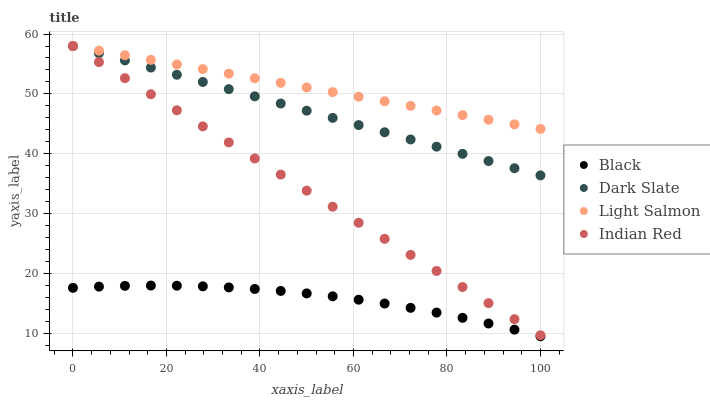Does Black have the minimum area under the curve?
Answer yes or no. Yes. Does Light Salmon have the maximum area under the curve?
Answer yes or no. Yes. Does Light Salmon have the minimum area under the curve?
Answer yes or no. No. Does Black have the maximum area under the curve?
Answer yes or no. No. Is Indian Red the smoothest?
Answer yes or no. Yes. Is Black the roughest?
Answer yes or no. Yes. Is Light Salmon the smoothest?
Answer yes or no. No. Is Light Salmon the roughest?
Answer yes or no. No. Does Black have the lowest value?
Answer yes or no. Yes. Does Light Salmon have the lowest value?
Answer yes or no. No. Does Indian Red have the highest value?
Answer yes or no. Yes. Does Black have the highest value?
Answer yes or no. No. Is Black less than Light Salmon?
Answer yes or no. Yes. Is Dark Slate greater than Black?
Answer yes or no. Yes. Does Dark Slate intersect Light Salmon?
Answer yes or no. Yes. Is Dark Slate less than Light Salmon?
Answer yes or no. No. Is Dark Slate greater than Light Salmon?
Answer yes or no. No. Does Black intersect Light Salmon?
Answer yes or no. No. 